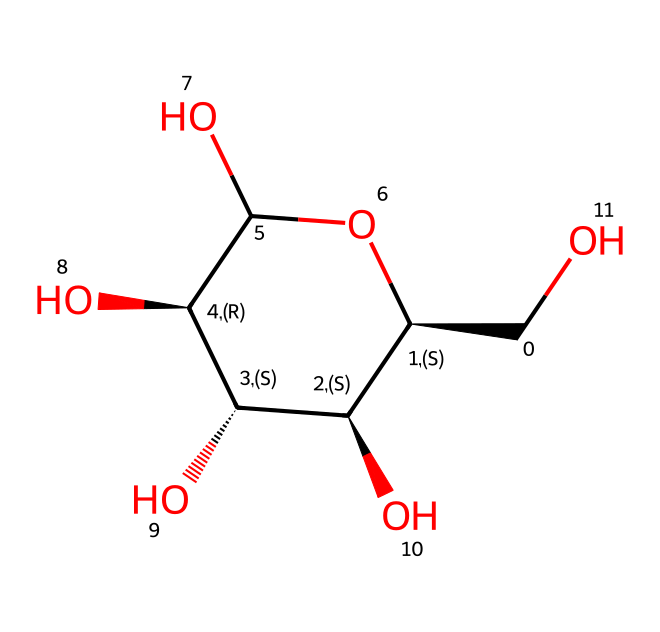How many carbon atoms are in this molecule? By examining the SMILES representation, we can identify the number of carbon atoms represented by 'C' in the structure. Counting each 'C', we find there are 6 carbon atoms in total.
Answer: 6 What type of carbohydrate is represented by this structure? The structure represents cellulose, which is a polysaccharide made of glucose units linked together. This can be inferred from the repeating units in the structure that correspond to glucose.
Answer: cellulose How many hydroxyl (–OH) groups are present? In the chemical structure, each –OH group can be identified by looking at where the oxygen atoms are directly bonded to hydrogen. Counting the visible –OH groups in the structure reveals there are 3.
Answer: 3 What is the degree of branching in this molecule? Cellulose has a linear structure with no branching. Analyzing the chemical structure, there are no branches off the main chain of carbon atoms, indicating a degree of branching of zero.
Answer: 0 Which functional group is predominantly found in cellulose? Cellulose extensively features hydroxyl (-OH) groups. The presence of these groups can be seen clearly in the structure, indicating that they are a significant part of cellulose.
Answer: hydroxyl group What type of glycosidic linkages are present in this structure? Cellulose is composed of beta-1,4-glycosidic linkages between glucose units. By inspecting the connections between the glucose units in the structure, we can confirm this linkage type.
Answer: beta-1,4 linkage 